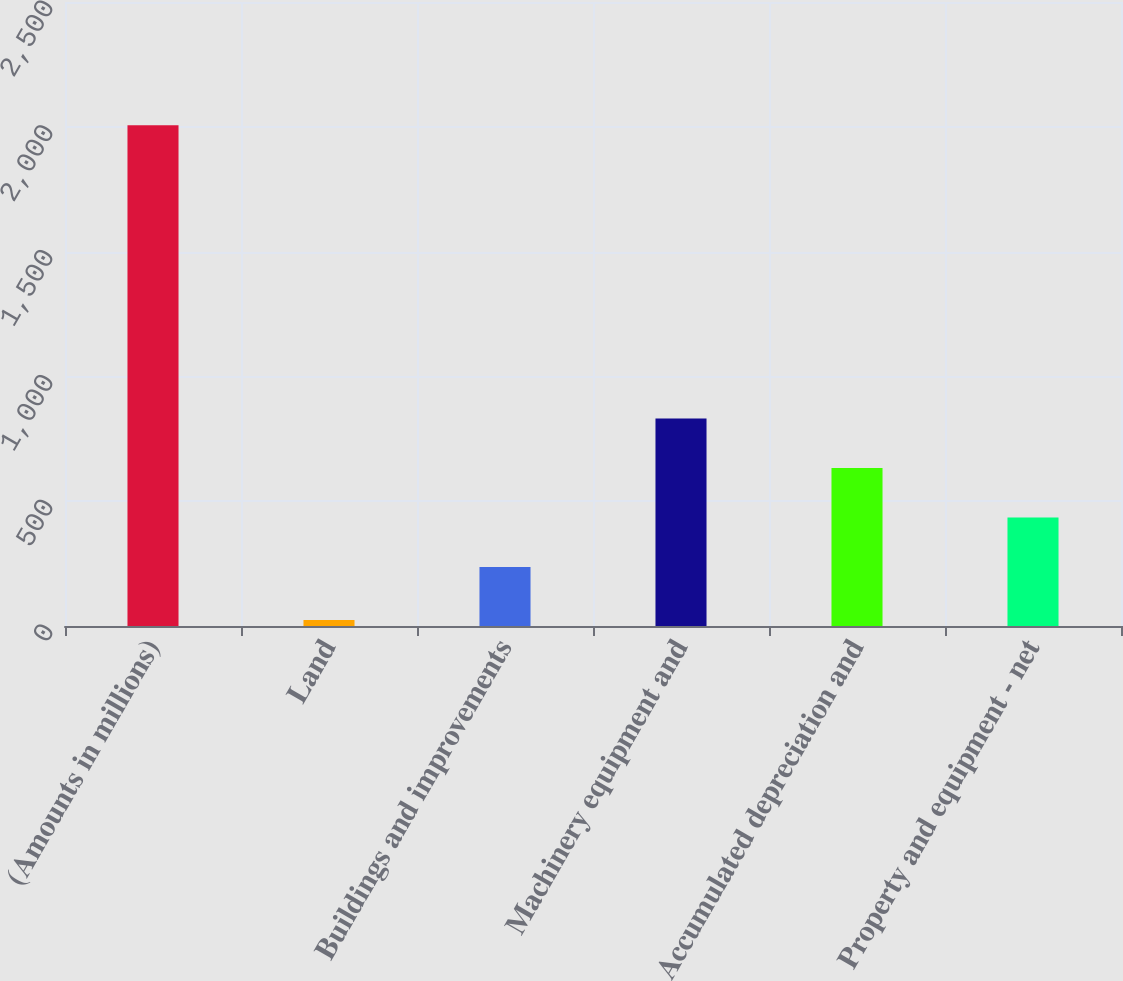<chart> <loc_0><loc_0><loc_500><loc_500><bar_chart><fcel>(Amounts in millions)<fcel>Land<fcel>Buildings and improvements<fcel>Machinery equipment and<fcel>Accumulated depreciation and<fcel>Property and equipment - net<nl><fcel>2006<fcel>24.3<fcel>236.7<fcel>831.21<fcel>633.04<fcel>434.87<nl></chart> 